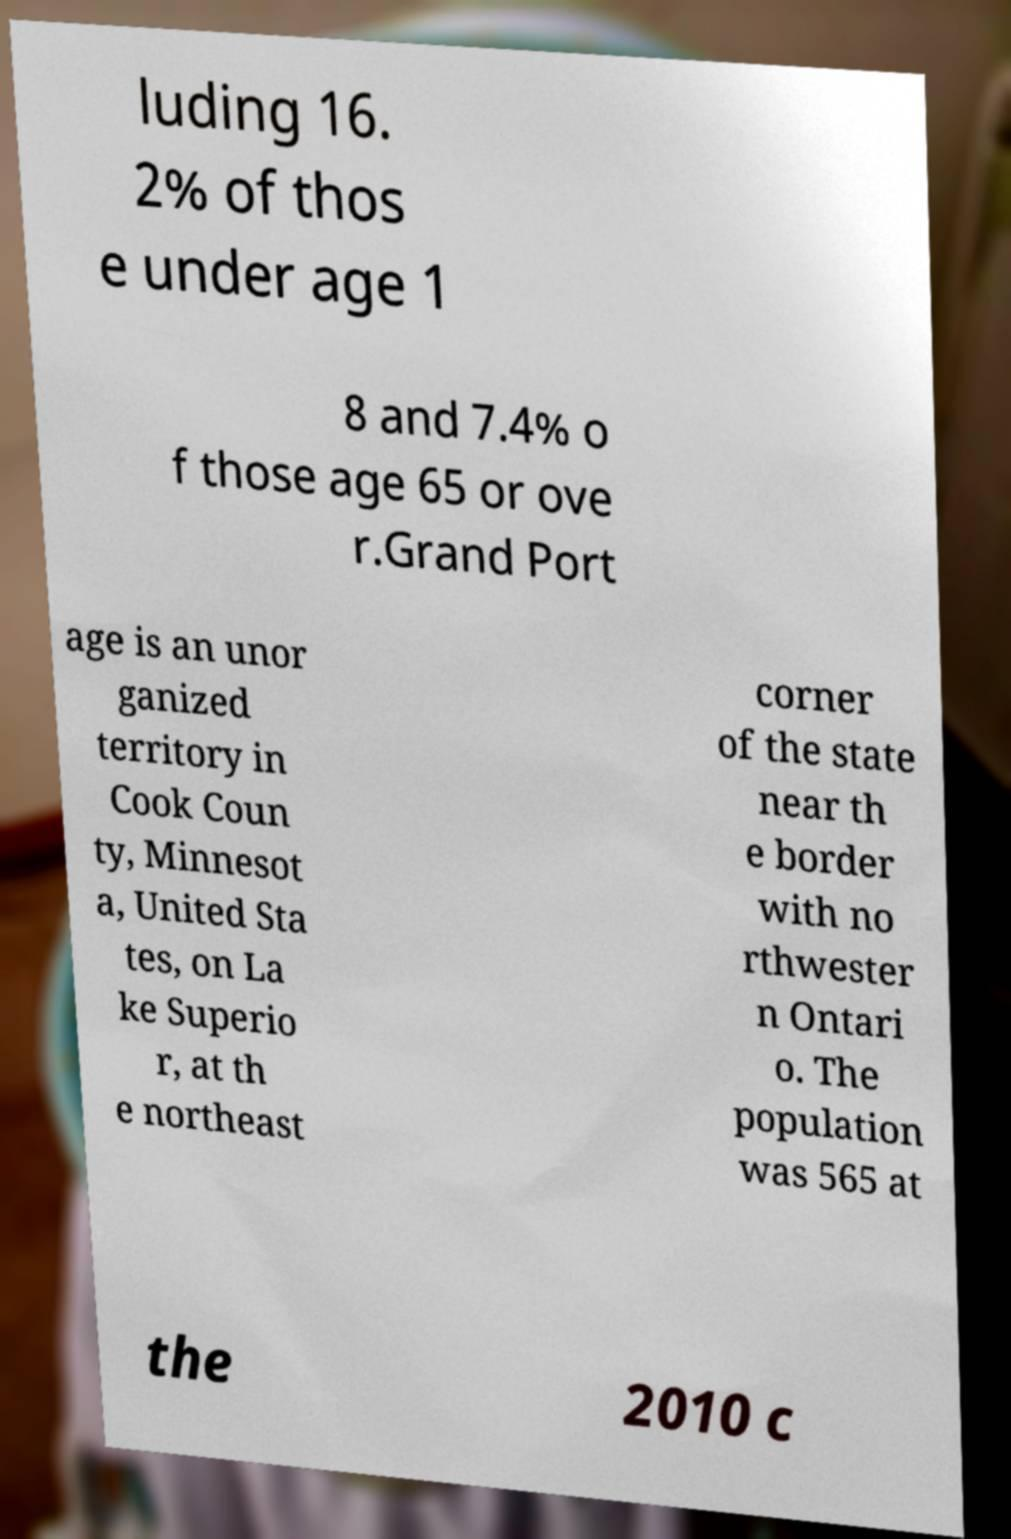For documentation purposes, I need the text within this image transcribed. Could you provide that? luding 16. 2% of thos e under age 1 8 and 7.4% o f those age 65 or ove r.Grand Port age is an unor ganized territory in Cook Coun ty, Minnesot a, United Sta tes, on La ke Superio r, at th e northeast corner of the state near th e border with no rthwester n Ontari o. The population was 565 at the 2010 c 